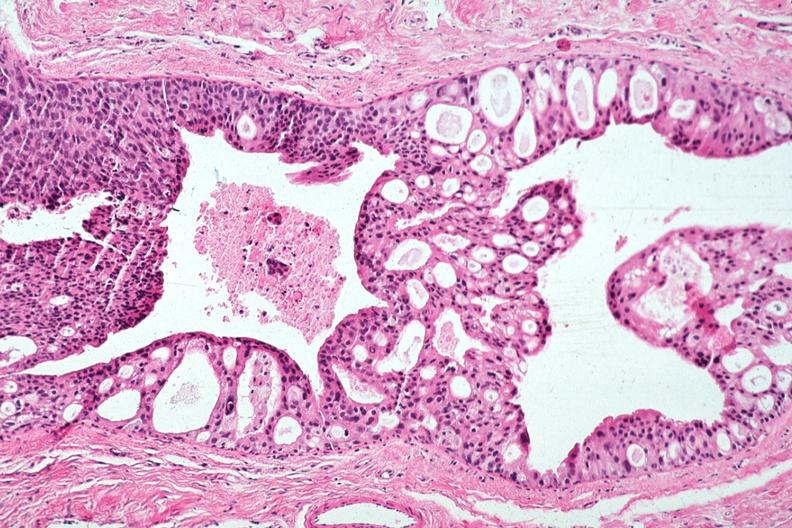s breast present?
Answer the question using a single word or phrase. Yes 